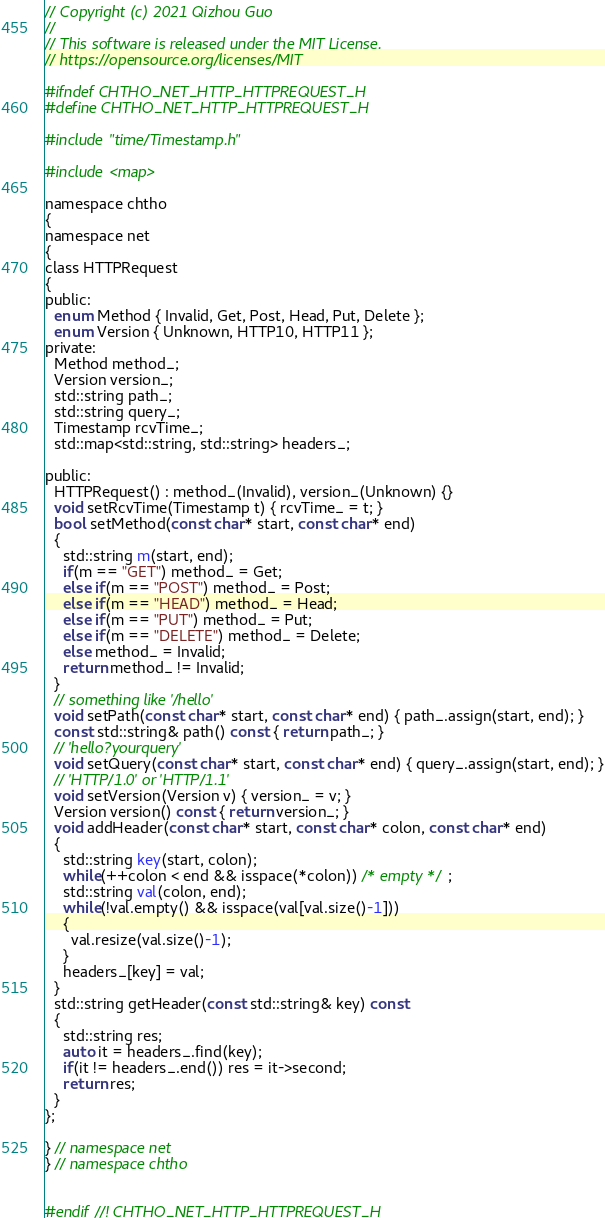Convert code to text. <code><loc_0><loc_0><loc_500><loc_500><_C_>// Copyright (c) 2021 Qizhou Guo
// 
// This software is released under the MIT License.
// https://opensource.org/licenses/MIT

#ifndef CHTHO_NET_HTTP_HTTPREQUEST_H
#define CHTHO_NET_HTTP_HTTPREQUEST_H

#include "time/Timestamp.h"

#include <map> 

namespace chtho
{
namespace net
{
class HTTPRequest
{
public:
  enum Method { Invalid, Get, Post, Head, Put, Delete };
  enum Version { Unknown, HTTP10, HTTP11 };
private:
  Method method_;
  Version version_;
  std::string path_;
  std::string query_;
  Timestamp rcvTime_;
  std::map<std::string, std::string> headers_; 

public:
  HTTPRequest() : method_(Invalid), version_(Unknown) {} 
  void setRcvTime(Timestamp t) { rcvTime_ = t; }
  bool setMethod(const char* start, const char* end)
  {
    std::string m(start, end);
    if(m == "GET") method_ = Get;
    else if(m == "POST") method_ = Post;
    else if(m == "HEAD") method_ = Head;
    else if(m == "PUT") method_ = Put;
    else if(m == "DELETE") method_ = Delete;
    else method_ = Invalid;
    return method_ != Invalid;
  }
  // something like '/hello'
  void setPath(const char* start, const char* end) { path_.assign(start, end); }
  const std::string& path() const { return path_; }
  // 'hello?yourquery'
  void setQuery(const char* start, const char* end) { query_.assign(start, end); }
  // 'HTTP/1.0' or 'HTTP/1.1' 
  void setVersion(Version v) { version_ = v; }
  Version version() const { return version_; }
  void addHeader(const char* start, const char* colon, const char* end)
  {
    std::string key(start, colon);
    while(++colon < end && isspace(*colon)) /* empty */ ;
    std::string val(colon, end);
    while(!val.empty() && isspace(val[val.size()-1]))
    {
      val.resize(val.size()-1);
    }
    headers_[key] = val; 
  }
  std::string getHeader(const std::string& key) const 
  {
    std::string res;
    auto it = headers_.find(key);
    if(it != headers_.end()) res = it->second;
    return res; 
  }
};
  
} // namespace net
} // namespace chtho


#endif //! CHTHO_NET_HTTP_HTTPREQUEST_H</code> 